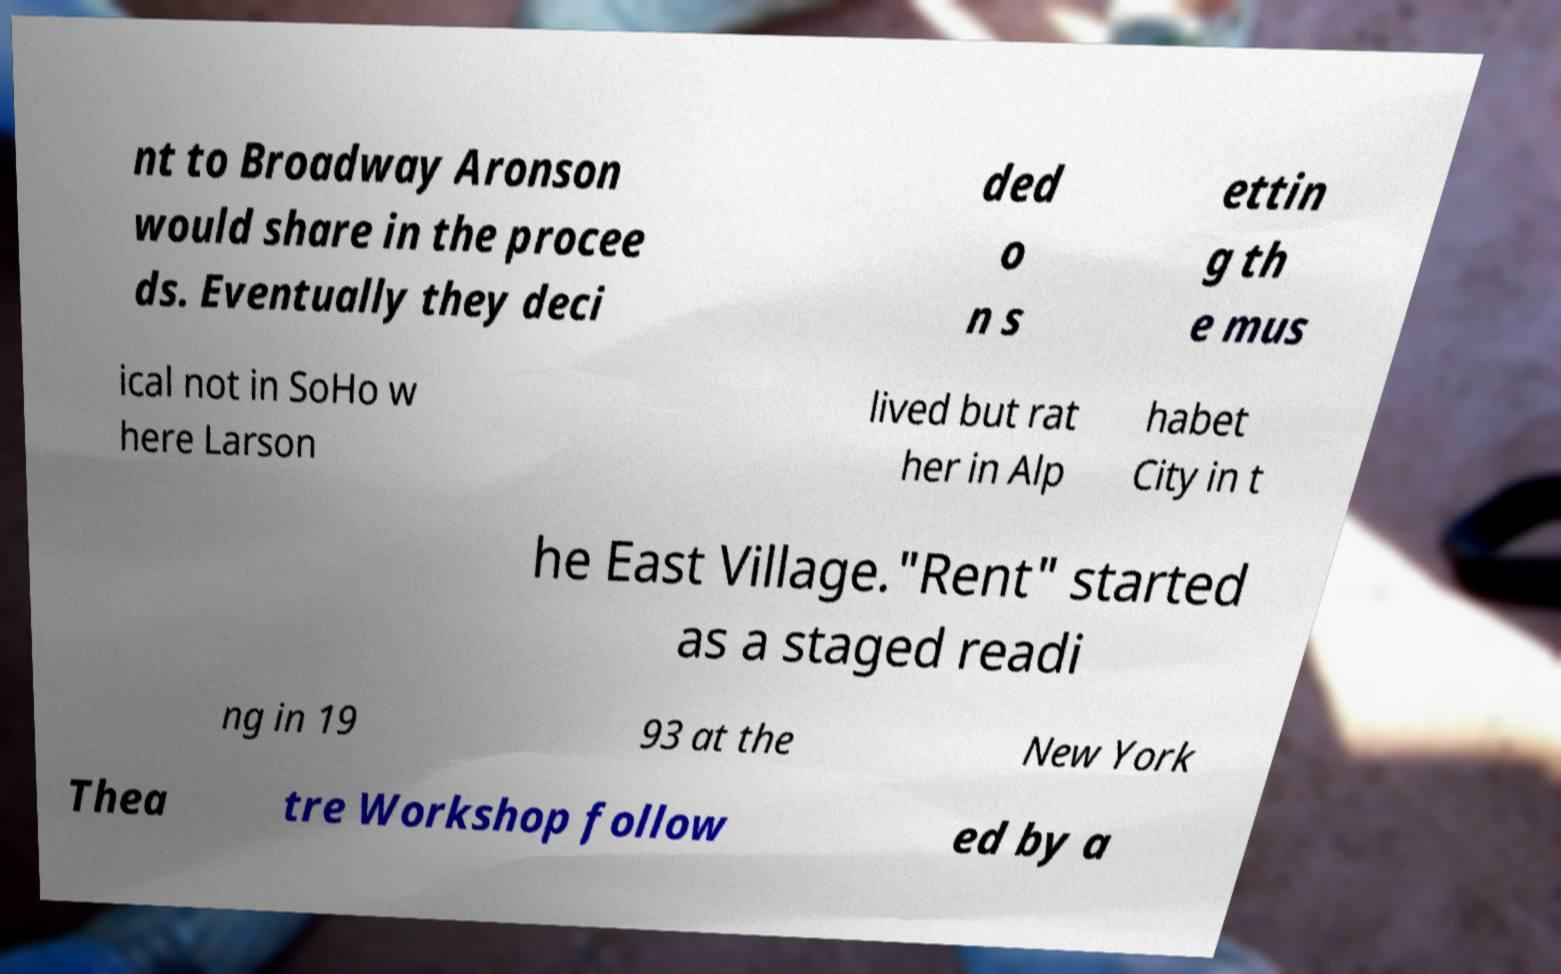Could you assist in decoding the text presented in this image and type it out clearly? nt to Broadway Aronson would share in the procee ds. Eventually they deci ded o n s ettin g th e mus ical not in SoHo w here Larson lived but rat her in Alp habet City in t he East Village."Rent" started as a staged readi ng in 19 93 at the New York Thea tre Workshop follow ed by a 